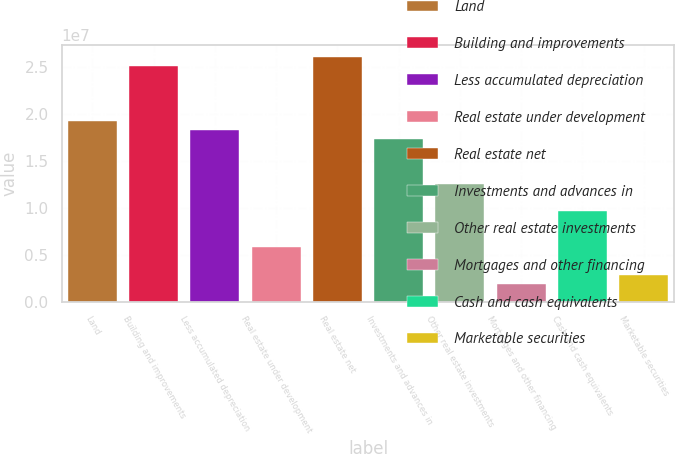Convert chart to OTSL. <chart><loc_0><loc_0><loc_500><loc_500><bar_chart><fcel>Land<fcel>Building and improvements<fcel>Less accumulated depreciation<fcel>Real estate under development<fcel>Real estate net<fcel>Investments and advances in<fcel>Other real estate investments<fcel>Mortgages and other financing<fcel>Cash and cash equivalents<fcel>Marketable securities<nl><fcel>1.93272e+07<fcel>2.51253e+07<fcel>1.83608e+07<fcel>5.79822e+06<fcel>2.60916e+07<fcel>1.73945e+07<fcel>1.25627e+07<fcel>1.93281e+06<fcel>9.66363e+06<fcel>2.89916e+06<nl></chart> 